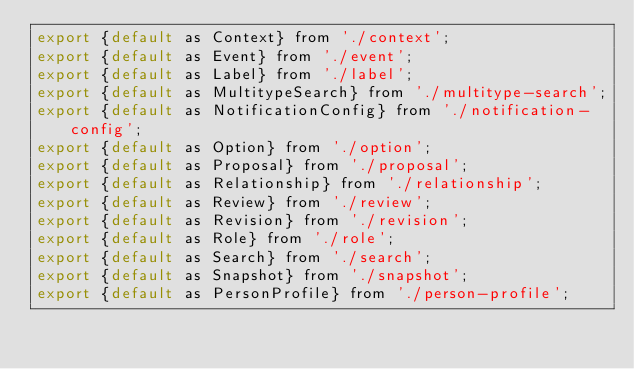<code> <loc_0><loc_0><loc_500><loc_500><_JavaScript_>export {default as Context} from './context';
export {default as Event} from './event';
export {default as Label} from './label';
export {default as MultitypeSearch} from './multitype-search';
export {default as NotificationConfig} from './notification-config';
export {default as Option} from './option';
export {default as Proposal} from './proposal';
export {default as Relationship} from './relationship';
export {default as Review} from './review';
export {default as Revision} from './revision';
export {default as Role} from './role';
export {default as Search} from './search';
export {default as Snapshot} from './snapshot';
export {default as PersonProfile} from './person-profile';
</code> 